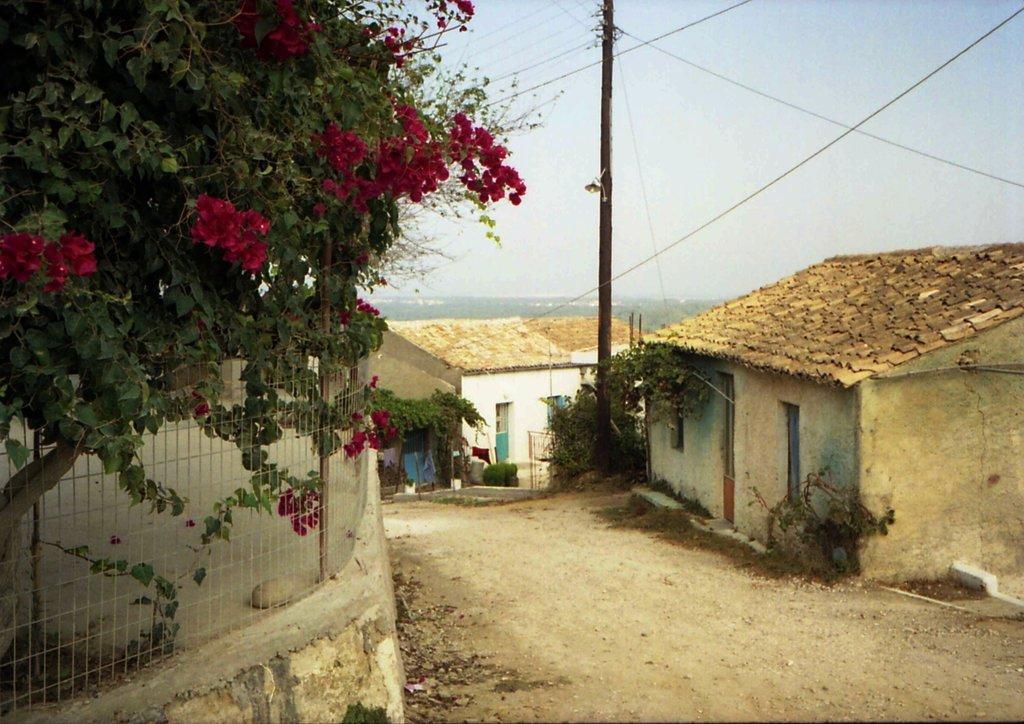Can you describe this image briefly? In the image in the center, we can see buildings, windows, trees, clothes, plants, wires, one pole, fence and flowers, which are in red color. In the background we can see the sky etc. 